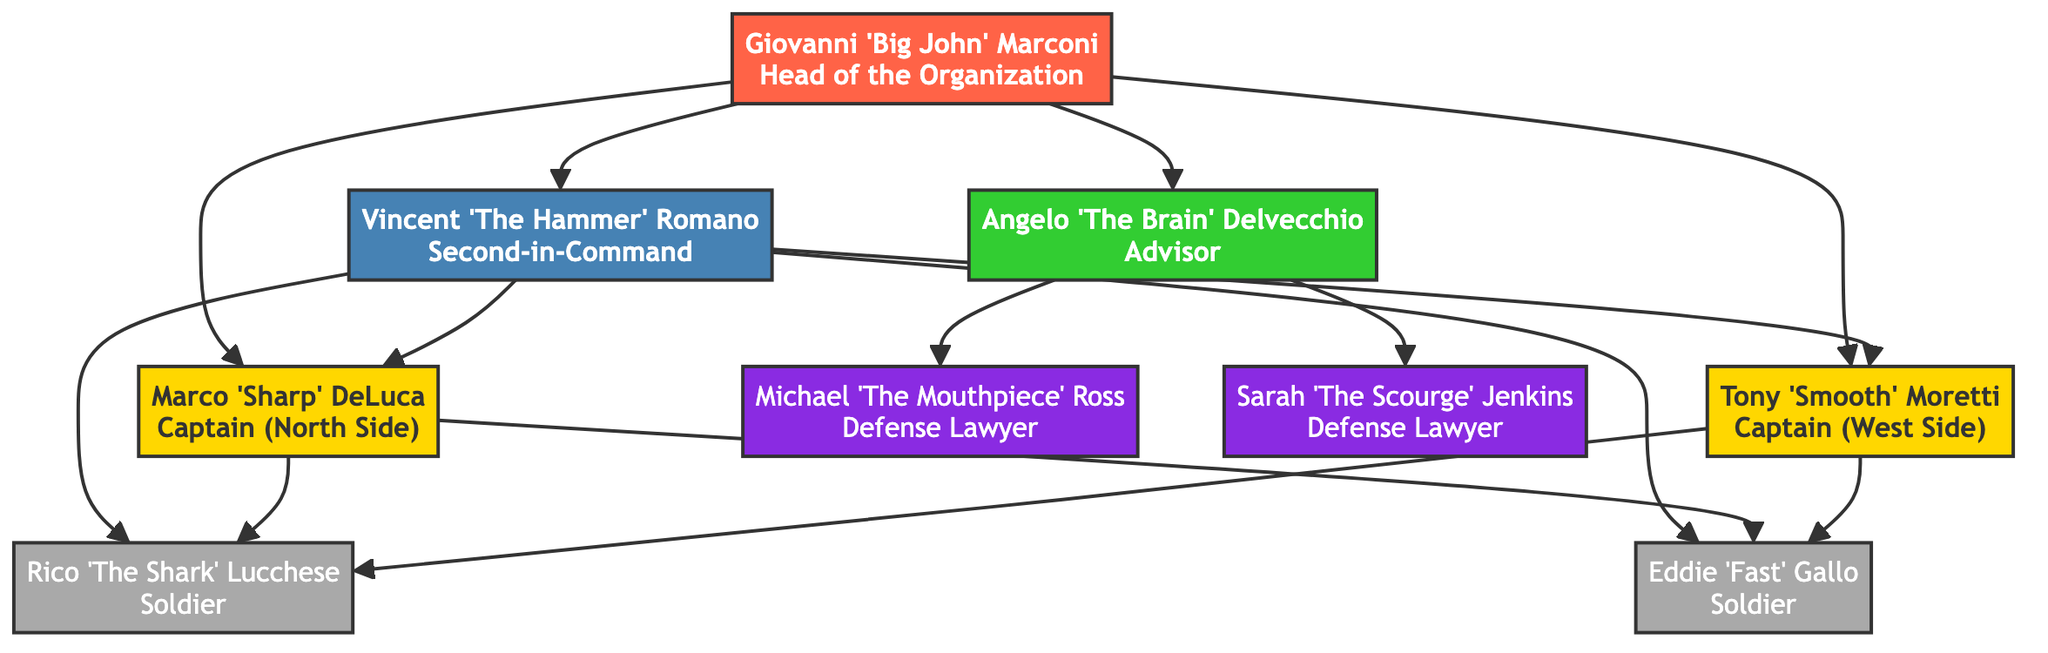What is the role of Giovanni 'Big John' Marconi? Giovanni 'Big John' Marconi is labeled as the "Head of the Organization," indicating he is the leader.
Answer: Head of the Organization How many Capos are there in the organization? There are two Capos specified in the diagram: Marco 'Sharp' DeLuca and Tony 'Smooth' Moretti.
Answer: 2 Who is directly connected to the Consigliere? The Consigliere, Angelo 'The Brain' Delvecchio, is connected to the Boss, Underboss, and the Legal Team members, which include Michael 'The Mouthpiece' Ross and Sarah 'The Scourge' Jenkins.
Answer: Boss, Underboss, Legal Team What territory does Marco 'Sharp' DeLuca cover? The diagram notes that Marco 'Sharp' DeLuca is the Captain of the North Side, indicating the area he oversees.
Answer: North Side Which role is second in command in the organization? The diagram shows that the Underboss, Vincent 'The Hammer' Romano, holds the position of second in command to the Boss.
Answer: Underboss Which two roles share connections to Soldiers? Both the Underboss and the Capos are connected to Soldiers, indicating their hierarchy in terms of overseeing Soldiers.
Answer: Underboss, Capos Who are the defense lawyers connected to the Consigliere? The diagram indicates that the Legal Team includes Michael 'The Mouthpiece' Ross and Sarah 'The Scourge' Jenkins as the defense lawyers connected to the Consigliere.
Answer: Michael 'The Mouthpiece' Ross, Sarah 'The Scourge' Jenkins What is the primary function of the Consigliere? The Consigliere is labeled as the "Advisor," which denotes their role within the organization.
Answer: Advisor List the names of the Soldiers in the organization. The diagram shows Rico 'The Shark' Lucchese and Eddie 'Fast' Gallo as the Soldiers in the organization.
Answer: Rico 'The Shark' Lucchese, Eddie 'Fast' Gallo 